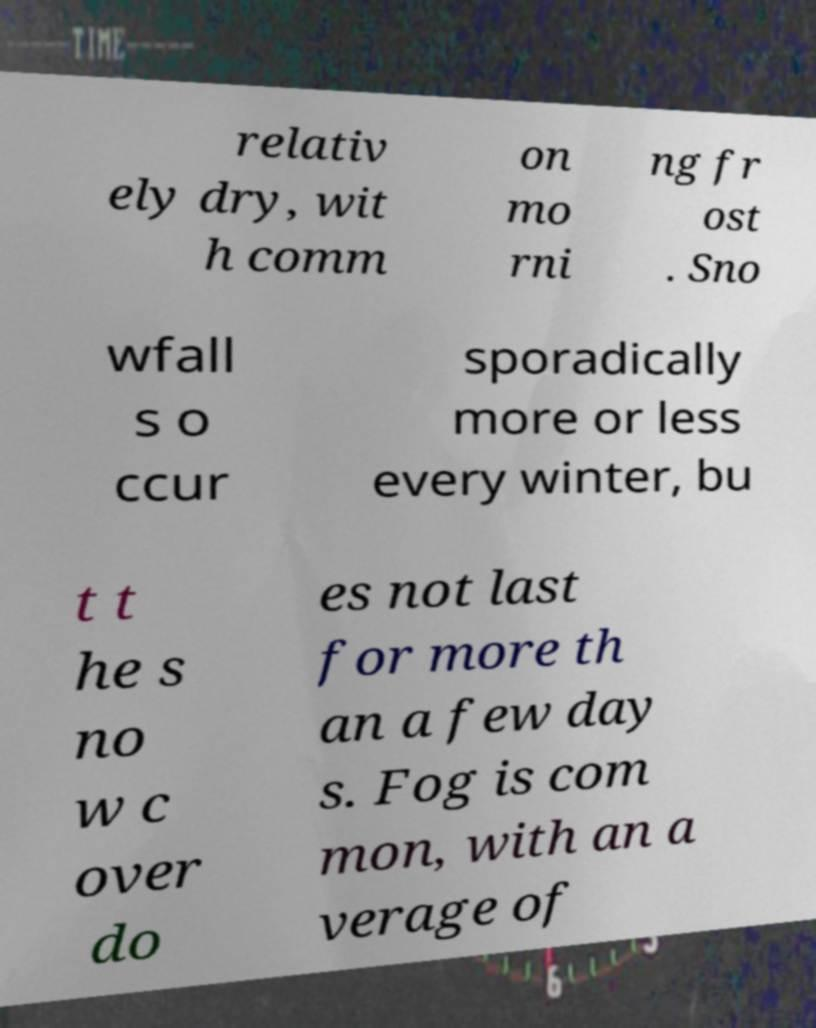For documentation purposes, I need the text within this image transcribed. Could you provide that? relativ ely dry, wit h comm on mo rni ng fr ost . Sno wfall s o ccur sporadically more or less every winter, bu t t he s no w c over do es not last for more th an a few day s. Fog is com mon, with an a verage of 